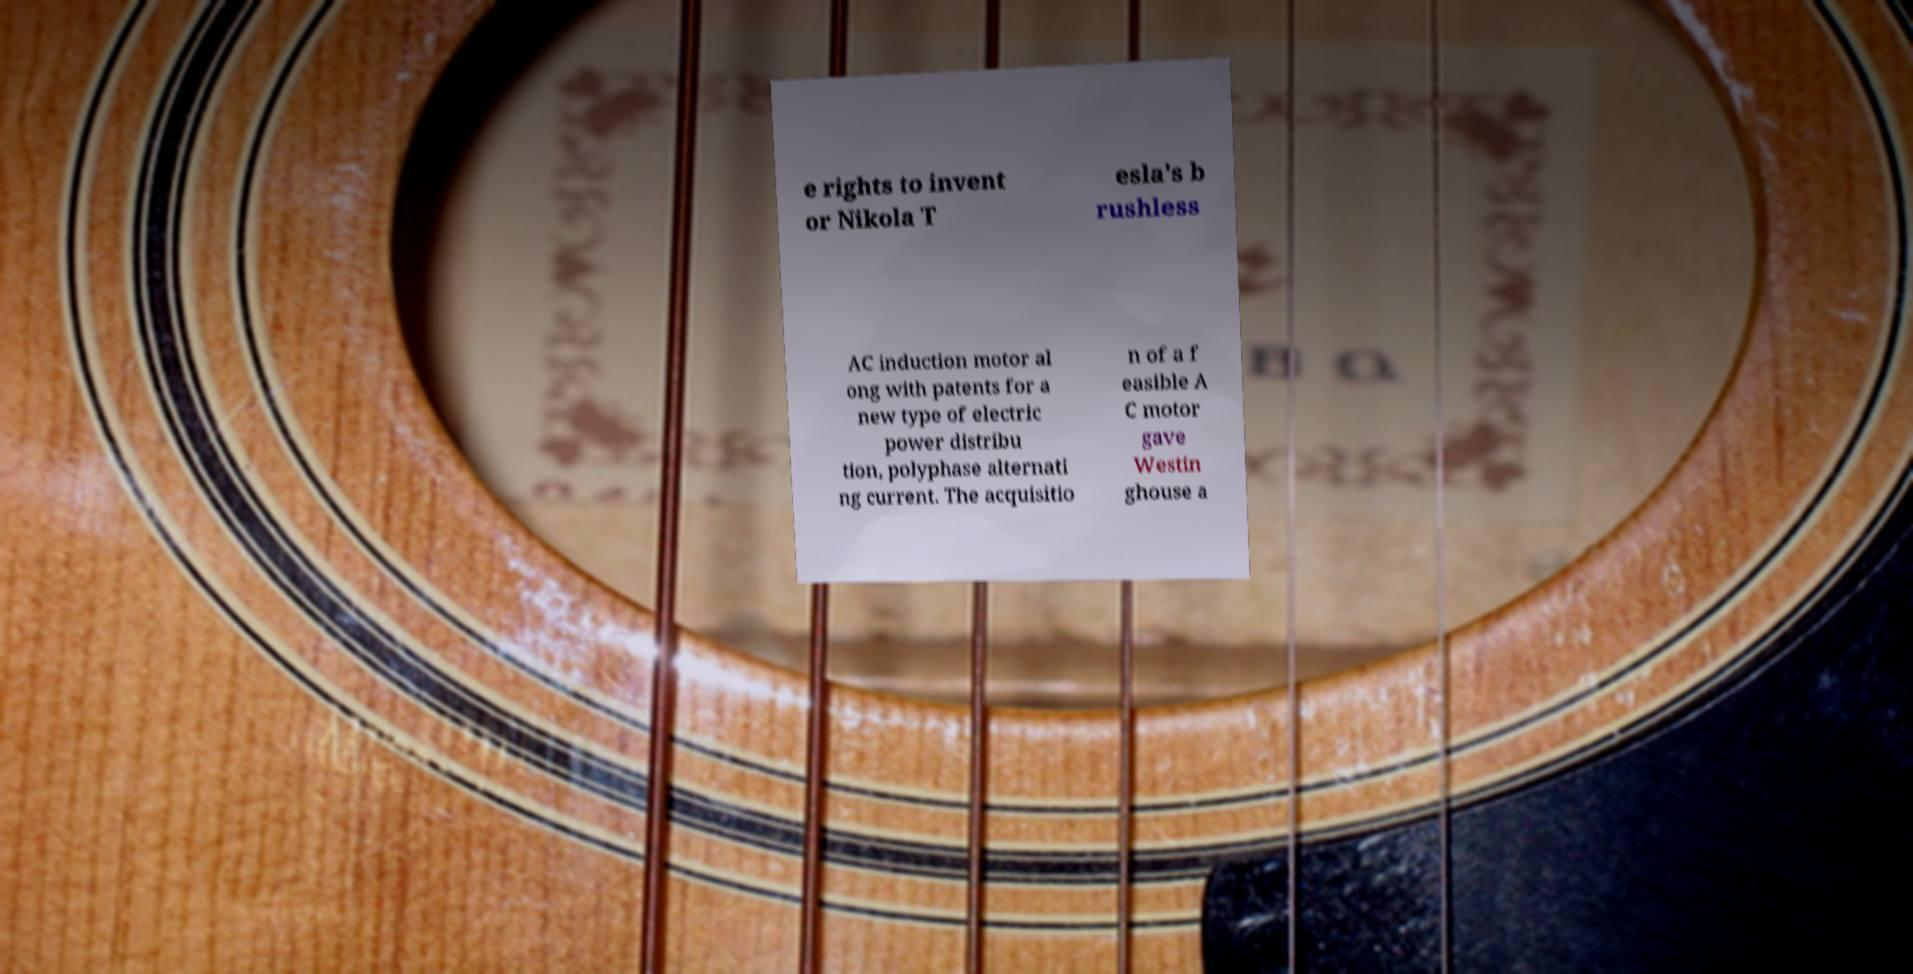I need the written content from this picture converted into text. Can you do that? e rights to invent or Nikola T esla's b rushless AC induction motor al ong with patents for a new type of electric power distribu tion, polyphase alternati ng current. The acquisitio n of a f easible A C motor gave Westin ghouse a 